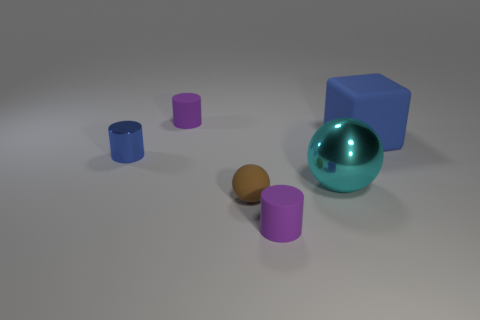What is the context or setting this image is trying to convey? The context appears to be a simplistic, artificially lit setting possibly created for a study or demonstration of geometry, lighting, and basic color theories. The lack of additional elements suggests an educational or demonstrative purpose. Could these objects have a practical use? While they could serve as teaching aids for geometry or physics lessons, their primary function in this image seems to be for visual demonstration rather than practical application. 